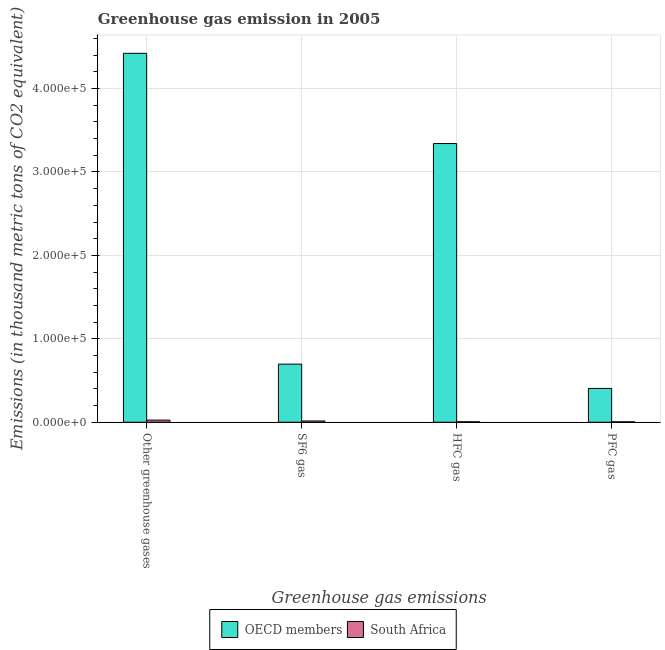How many different coloured bars are there?
Your answer should be compact. 2. Are the number of bars on each tick of the X-axis equal?
Keep it short and to the point. Yes. How many bars are there on the 1st tick from the left?
Provide a short and direct response. 2. What is the label of the 4th group of bars from the left?
Give a very brief answer. PFC gas. What is the emission of hfc gas in South Africa?
Your answer should be very brief. 524.5. Across all countries, what is the maximum emission of sf6 gas?
Your response must be concise. 6.96e+04. Across all countries, what is the minimum emission of hfc gas?
Keep it short and to the point. 524.5. In which country was the emission of hfc gas minimum?
Ensure brevity in your answer.  South Africa. What is the total emission of pfc gas in the graph?
Your answer should be very brief. 4.10e+04. What is the difference between the emission of pfc gas in South Africa and that in OECD members?
Make the answer very short. -4.00e+04. What is the difference between the emission of greenhouse gases in South Africa and the emission of pfc gas in OECD members?
Your answer should be very brief. -3.80e+04. What is the average emission of greenhouse gases per country?
Your answer should be compact. 2.22e+05. What is the difference between the emission of greenhouse gases and emission of hfc gas in OECD members?
Give a very brief answer. 1.08e+05. In how many countries, is the emission of pfc gas greater than 140000 thousand metric tons?
Your answer should be very brief. 0. What is the ratio of the emission of sf6 gas in OECD members to that in South Africa?
Ensure brevity in your answer.  45.83. Is the difference between the emission of hfc gas in OECD members and South Africa greater than the difference between the emission of pfc gas in OECD members and South Africa?
Provide a short and direct response. Yes. What is the difference between the highest and the second highest emission of greenhouse gases?
Provide a short and direct response. 4.40e+05. What is the difference between the highest and the lowest emission of greenhouse gases?
Your answer should be very brief. 4.40e+05. In how many countries, is the emission of hfc gas greater than the average emission of hfc gas taken over all countries?
Ensure brevity in your answer.  1. Is it the case that in every country, the sum of the emission of sf6 gas and emission of hfc gas is greater than the sum of emission of greenhouse gases and emission of pfc gas?
Your response must be concise. No. What does the 1st bar from the right in Other greenhouse gases represents?
Keep it short and to the point. South Africa. Is it the case that in every country, the sum of the emission of greenhouse gases and emission of sf6 gas is greater than the emission of hfc gas?
Offer a terse response. Yes. How many bars are there?
Provide a succinct answer. 8. Are all the bars in the graph horizontal?
Offer a very short reply. No. How many countries are there in the graph?
Give a very brief answer. 2. Are the values on the major ticks of Y-axis written in scientific E-notation?
Ensure brevity in your answer.  Yes. Does the graph contain grids?
Keep it short and to the point. Yes. Where does the legend appear in the graph?
Your answer should be very brief. Bottom center. How many legend labels are there?
Give a very brief answer. 2. What is the title of the graph?
Ensure brevity in your answer.  Greenhouse gas emission in 2005. What is the label or title of the X-axis?
Make the answer very short. Greenhouse gas emissions. What is the label or title of the Y-axis?
Your answer should be compact. Emissions (in thousand metric tons of CO2 equivalent). What is the Emissions (in thousand metric tons of CO2 equivalent) of OECD members in Other greenhouse gases?
Ensure brevity in your answer.  4.42e+05. What is the Emissions (in thousand metric tons of CO2 equivalent) of South Africa in Other greenhouse gases?
Offer a terse response. 2544. What is the Emissions (in thousand metric tons of CO2 equivalent) of OECD members in SF6 gas?
Provide a short and direct response. 6.96e+04. What is the Emissions (in thousand metric tons of CO2 equivalent) in South Africa in SF6 gas?
Your response must be concise. 1519.7. What is the Emissions (in thousand metric tons of CO2 equivalent) of OECD members in HFC gas?
Provide a succinct answer. 3.34e+05. What is the Emissions (in thousand metric tons of CO2 equivalent) of South Africa in HFC gas?
Ensure brevity in your answer.  524.5. What is the Emissions (in thousand metric tons of CO2 equivalent) in OECD members in PFC gas?
Provide a succinct answer. 4.05e+04. What is the Emissions (in thousand metric tons of CO2 equivalent) of South Africa in PFC gas?
Your answer should be compact. 499.8. Across all Greenhouse gas emissions, what is the maximum Emissions (in thousand metric tons of CO2 equivalent) in OECD members?
Offer a terse response. 4.42e+05. Across all Greenhouse gas emissions, what is the maximum Emissions (in thousand metric tons of CO2 equivalent) in South Africa?
Your response must be concise. 2544. Across all Greenhouse gas emissions, what is the minimum Emissions (in thousand metric tons of CO2 equivalent) of OECD members?
Keep it short and to the point. 4.05e+04. Across all Greenhouse gas emissions, what is the minimum Emissions (in thousand metric tons of CO2 equivalent) in South Africa?
Make the answer very short. 499.8. What is the total Emissions (in thousand metric tons of CO2 equivalent) in OECD members in the graph?
Your answer should be very brief. 8.86e+05. What is the total Emissions (in thousand metric tons of CO2 equivalent) in South Africa in the graph?
Ensure brevity in your answer.  5088. What is the difference between the Emissions (in thousand metric tons of CO2 equivalent) of OECD members in Other greenhouse gases and that in SF6 gas?
Your answer should be compact. 3.73e+05. What is the difference between the Emissions (in thousand metric tons of CO2 equivalent) in South Africa in Other greenhouse gases and that in SF6 gas?
Give a very brief answer. 1024.3. What is the difference between the Emissions (in thousand metric tons of CO2 equivalent) in OECD members in Other greenhouse gases and that in HFC gas?
Offer a very short reply. 1.08e+05. What is the difference between the Emissions (in thousand metric tons of CO2 equivalent) in South Africa in Other greenhouse gases and that in HFC gas?
Provide a succinct answer. 2019.5. What is the difference between the Emissions (in thousand metric tons of CO2 equivalent) of OECD members in Other greenhouse gases and that in PFC gas?
Your answer should be compact. 4.02e+05. What is the difference between the Emissions (in thousand metric tons of CO2 equivalent) in South Africa in Other greenhouse gases and that in PFC gas?
Give a very brief answer. 2044.2. What is the difference between the Emissions (in thousand metric tons of CO2 equivalent) of OECD members in SF6 gas and that in HFC gas?
Give a very brief answer. -2.64e+05. What is the difference between the Emissions (in thousand metric tons of CO2 equivalent) of South Africa in SF6 gas and that in HFC gas?
Your answer should be very brief. 995.2. What is the difference between the Emissions (in thousand metric tons of CO2 equivalent) in OECD members in SF6 gas and that in PFC gas?
Your response must be concise. 2.91e+04. What is the difference between the Emissions (in thousand metric tons of CO2 equivalent) in South Africa in SF6 gas and that in PFC gas?
Make the answer very short. 1019.9. What is the difference between the Emissions (in thousand metric tons of CO2 equivalent) of OECD members in HFC gas and that in PFC gas?
Provide a succinct answer. 2.94e+05. What is the difference between the Emissions (in thousand metric tons of CO2 equivalent) in South Africa in HFC gas and that in PFC gas?
Give a very brief answer. 24.7. What is the difference between the Emissions (in thousand metric tons of CO2 equivalent) in OECD members in Other greenhouse gases and the Emissions (in thousand metric tons of CO2 equivalent) in South Africa in SF6 gas?
Offer a very short reply. 4.41e+05. What is the difference between the Emissions (in thousand metric tons of CO2 equivalent) in OECD members in Other greenhouse gases and the Emissions (in thousand metric tons of CO2 equivalent) in South Africa in HFC gas?
Provide a succinct answer. 4.42e+05. What is the difference between the Emissions (in thousand metric tons of CO2 equivalent) in OECD members in Other greenhouse gases and the Emissions (in thousand metric tons of CO2 equivalent) in South Africa in PFC gas?
Your response must be concise. 4.42e+05. What is the difference between the Emissions (in thousand metric tons of CO2 equivalent) of OECD members in SF6 gas and the Emissions (in thousand metric tons of CO2 equivalent) of South Africa in HFC gas?
Offer a very short reply. 6.91e+04. What is the difference between the Emissions (in thousand metric tons of CO2 equivalent) of OECD members in SF6 gas and the Emissions (in thousand metric tons of CO2 equivalent) of South Africa in PFC gas?
Give a very brief answer. 6.91e+04. What is the difference between the Emissions (in thousand metric tons of CO2 equivalent) in OECD members in HFC gas and the Emissions (in thousand metric tons of CO2 equivalent) in South Africa in PFC gas?
Ensure brevity in your answer.  3.34e+05. What is the average Emissions (in thousand metric tons of CO2 equivalent) in OECD members per Greenhouse gas emissions?
Provide a succinct answer. 2.22e+05. What is the average Emissions (in thousand metric tons of CO2 equivalent) in South Africa per Greenhouse gas emissions?
Keep it short and to the point. 1272. What is the difference between the Emissions (in thousand metric tons of CO2 equivalent) in OECD members and Emissions (in thousand metric tons of CO2 equivalent) in South Africa in Other greenhouse gases?
Your answer should be compact. 4.40e+05. What is the difference between the Emissions (in thousand metric tons of CO2 equivalent) of OECD members and Emissions (in thousand metric tons of CO2 equivalent) of South Africa in SF6 gas?
Ensure brevity in your answer.  6.81e+04. What is the difference between the Emissions (in thousand metric tons of CO2 equivalent) of OECD members and Emissions (in thousand metric tons of CO2 equivalent) of South Africa in HFC gas?
Keep it short and to the point. 3.34e+05. What is the difference between the Emissions (in thousand metric tons of CO2 equivalent) of OECD members and Emissions (in thousand metric tons of CO2 equivalent) of South Africa in PFC gas?
Give a very brief answer. 4.00e+04. What is the ratio of the Emissions (in thousand metric tons of CO2 equivalent) in OECD members in Other greenhouse gases to that in SF6 gas?
Your response must be concise. 6.35. What is the ratio of the Emissions (in thousand metric tons of CO2 equivalent) of South Africa in Other greenhouse gases to that in SF6 gas?
Give a very brief answer. 1.67. What is the ratio of the Emissions (in thousand metric tons of CO2 equivalent) of OECD members in Other greenhouse gases to that in HFC gas?
Offer a terse response. 1.32. What is the ratio of the Emissions (in thousand metric tons of CO2 equivalent) of South Africa in Other greenhouse gases to that in HFC gas?
Make the answer very short. 4.85. What is the ratio of the Emissions (in thousand metric tons of CO2 equivalent) in OECD members in Other greenhouse gases to that in PFC gas?
Offer a terse response. 10.91. What is the ratio of the Emissions (in thousand metric tons of CO2 equivalent) of South Africa in Other greenhouse gases to that in PFC gas?
Ensure brevity in your answer.  5.09. What is the ratio of the Emissions (in thousand metric tons of CO2 equivalent) in OECD members in SF6 gas to that in HFC gas?
Keep it short and to the point. 0.21. What is the ratio of the Emissions (in thousand metric tons of CO2 equivalent) of South Africa in SF6 gas to that in HFC gas?
Offer a terse response. 2.9. What is the ratio of the Emissions (in thousand metric tons of CO2 equivalent) in OECD members in SF6 gas to that in PFC gas?
Your response must be concise. 1.72. What is the ratio of the Emissions (in thousand metric tons of CO2 equivalent) of South Africa in SF6 gas to that in PFC gas?
Offer a terse response. 3.04. What is the ratio of the Emissions (in thousand metric tons of CO2 equivalent) in OECD members in HFC gas to that in PFC gas?
Keep it short and to the point. 8.25. What is the ratio of the Emissions (in thousand metric tons of CO2 equivalent) in South Africa in HFC gas to that in PFC gas?
Give a very brief answer. 1.05. What is the difference between the highest and the second highest Emissions (in thousand metric tons of CO2 equivalent) of OECD members?
Offer a very short reply. 1.08e+05. What is the difference between the highest and the second highest Emissions (in thousand metric tons of CO2 equivalent) of South Africa?
Offer a very short reply. 1024.3. What is the difference between the highest and the lowest Emissions (in thousand metric tons of CO2 equivalent) of OECD members?
Provide a short and direct response. 4.02e+05. What is the difference between the highest and the lowest Emissions (in thousand metric tons of CO2 equivalent) of South Africa?
Offer a terse response. 2044.2. 